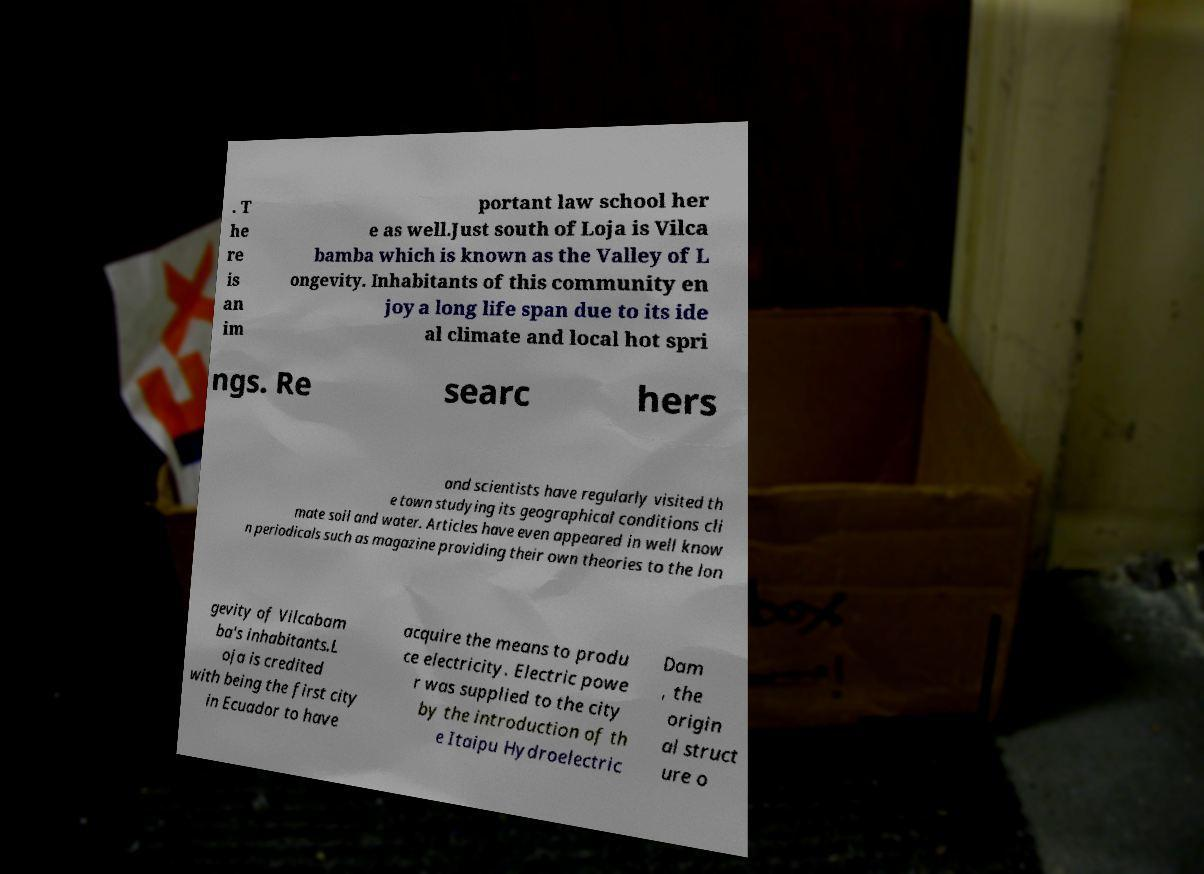Please read and relay the text visible in this image. What does it say? . T he re is an im portant law school her e as well.Just south of Loja is Vilca bamba which is known as the Valley of L ongevity. Inhabitants of this community en joy a long life span due to its ide al climate and local hot spri ngs. Re searc hers and scientists have regularly visited th e town studying its geographical conditions cli mate soil and water. Articles have even appeared in well know n periodicals such as magazine providing their own theories to the lon gevity of Vilcabam ba's inhabitants.L oja is credited with being the first city in Ecuador to have acquire the means to produ ce electricity. Electric powe r was supplied to the city by the introduction of th e Itaipu Hydroelectric Dam , the origin al struct ure o 